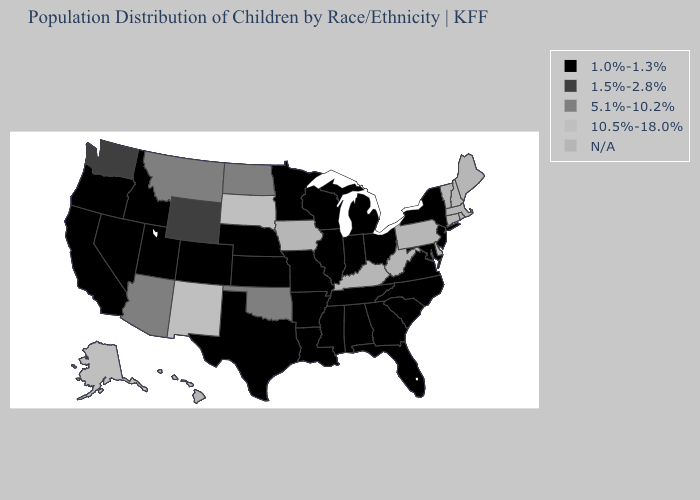Name the states that have a value in the range 10.5%-18.0%?
Be succinct. Alaska, New Mexico, South Dakota. Does Oklahoma have the highest value in the South?
Concise answer only. Yes. What is the highest value in the USA?
Answer briefly. 10.5%-18.0%. Name the states that have a value in the range 5.1%-10.2%?
Quick response, please. Arizona, Montana, North Dakota, Oklahoma. What is the highest value in states that border Connecticut?
Short answer required. 1.0%-1.3%. Name the states that have a value in the range 10.5%-18.0%?
Quick response, please. Alaska, New Mexico, South Dakota. Among the states that border Montana , does South Dakota have the highest value?
Concise answer only. Yes. Among the states that border North Dakota , which have the lowest value?
Concise answer only. Minnesota. What is the value of West Virginia?
Quick response, please. N/A. What is the value of Minnesota?
Write a very short answer. 1.0%-1.3%. Does the map have missing data?
Short answer required. Yes. What is the value of Alabama?
Concise answer only. 1.0%-1.3%. Which states have the highest value in the USA?
Keep it brief. Alaska, New Mexico, South Dakota. 